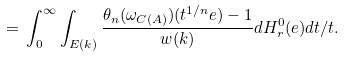<formula> <loc_0><loc_0><loc_500><loc_500>\, = \, \int _ { 0 } ^ { \infty } \int _ { E ( k ) } \frac { \theta _ { n } ( \omega _ { C ( A ) } ) ( t ^ { 1 / n } e ) - 1 } { w ( k ) } d H _ { r } ^ { 0 } ( e ) d t / t .</formula> 